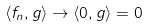Convert formula to latex. <formula><loc_0><loc_0><loc_500><loc_500>\langle f _ { n } , g \rangle \rightarrow \langle 0 , g \rangle = 0</formula> 